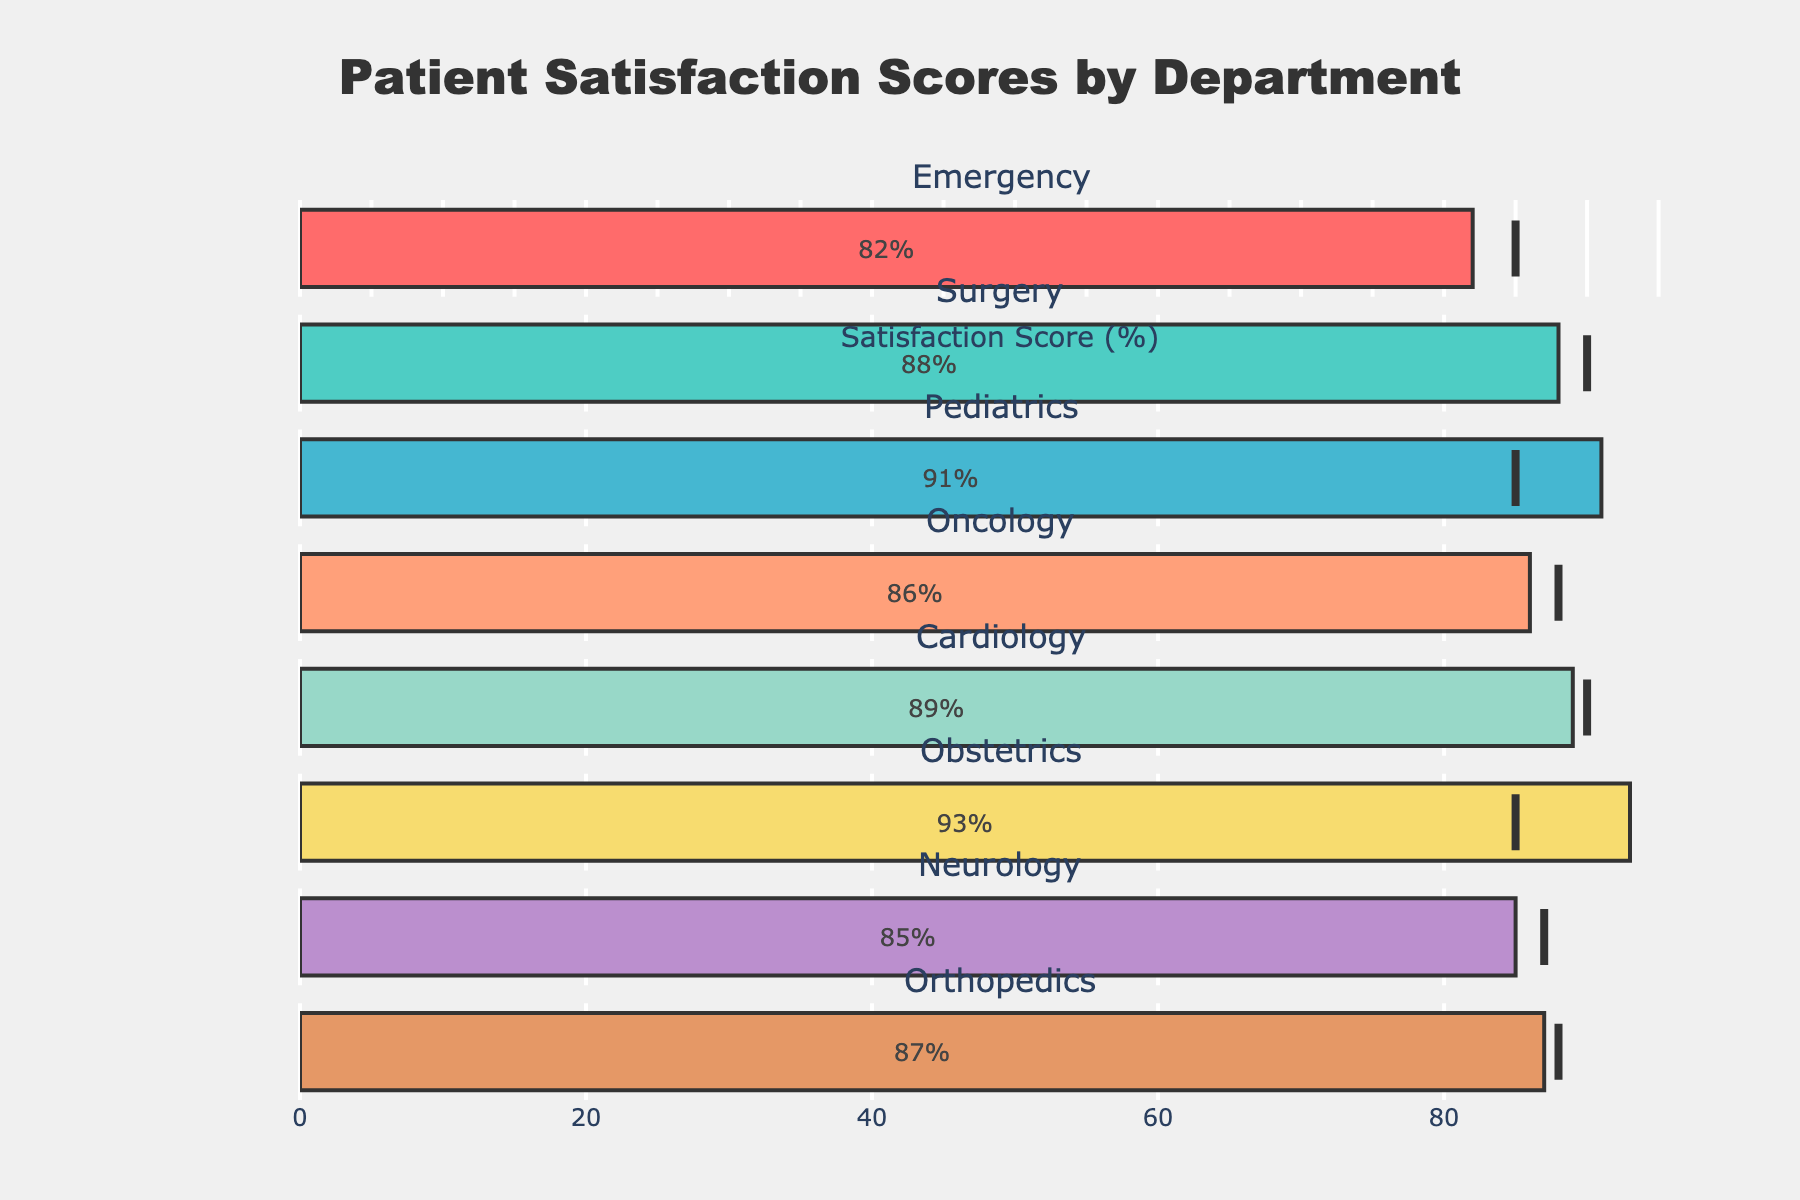How many departments are displayed in the figure? Count the number of individual departments shown on the y-axis. There are 8 departments listed: Emergency, Surgery, Pediatrics, Oncology, Cardiology, Obstetrics, Neurology, and Orthopedics.
Answer: 8 What is the title of the chart? The title is usually positioned at the top of the chart, centered for emphasis. The title given is "Patient Satisfaction Scores by Department."
Answer: Patient Satisfaction Scores by Department Which department has the highest patient satisfaction score? Review the bars and note which extends the furthest to the right. The Obstetrics department has the highest score with an actual value of 93%.
Answer: Obstetrics Which department's actual satisfaction score falls farthest below its target? Calculate the difference between the actual and target scores for each department. The Emergency department's actual score (82%) is 3 percentage points below its target (85%).
Answer: Emergency What is the color code used for the Neurology department? Identify the color of the Neurology department bar in the chart. Neurology is shown in a distinct color to differentiate it from other departments. The Neurology department uses a specific color from the provided list (#E59866).
Answer: #E59866 Which departments exceeded their target satisfaction scores? Compare each department's actual score against its target. Both Obstetrics (93 vs. 85) and Pediatrics (91 vs. 85) scores are higher than their target values.
Answer: Obstetrics, Pediatrics By how much does the Cardiology department's actual score differ from its target? Subtract the target score from the actual score for Cardiology. The actual score (89%) minus the target (90%) gives a difference of -1%.
Answer: -1% What's the average patient satisfaction score across all the departments? Sum all the actual scores and divide by the number of departments. (82+88+91+86+89+93+85+87)/8 = 700/8 = 87.5%.
Answer: 87.5% Are there any departments with actual satisfaction scores exactly equal to their target? Compare the actual and target values for each department. No departments have actual scores exactly equal to their targets.
Answer: No What's the median target satisfaction score among all departments? List all target scores, order them, and identify the middle value. The target scores in order are: 85, 85, 85, 87, 88, 88, 90, 90. The median of these values is between the 4th and 5th values (87+88)/2 = 87.5.
Answer: 87.5 